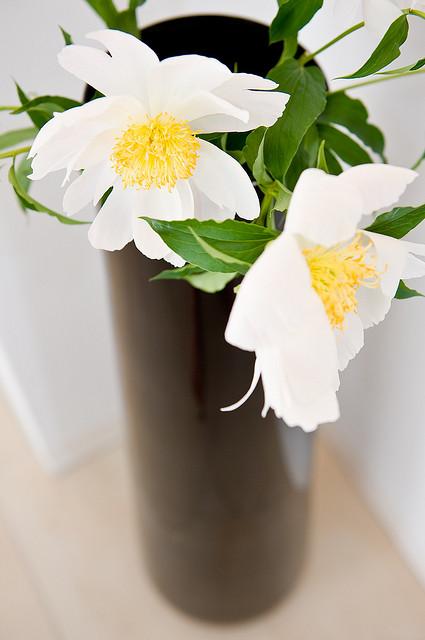Is the flower vase in focus or out of focus?
Concise answer only. Out of focus. What color is the pitcher?
Quick response, please. Black. What color is the flower?
Give a very brief answer. White. What color are the flowers?
Concise answer only. White. Are the flowers artificial?
Answer briefly. No. Are the flowers pretty?
Concise answer only. Yes. 